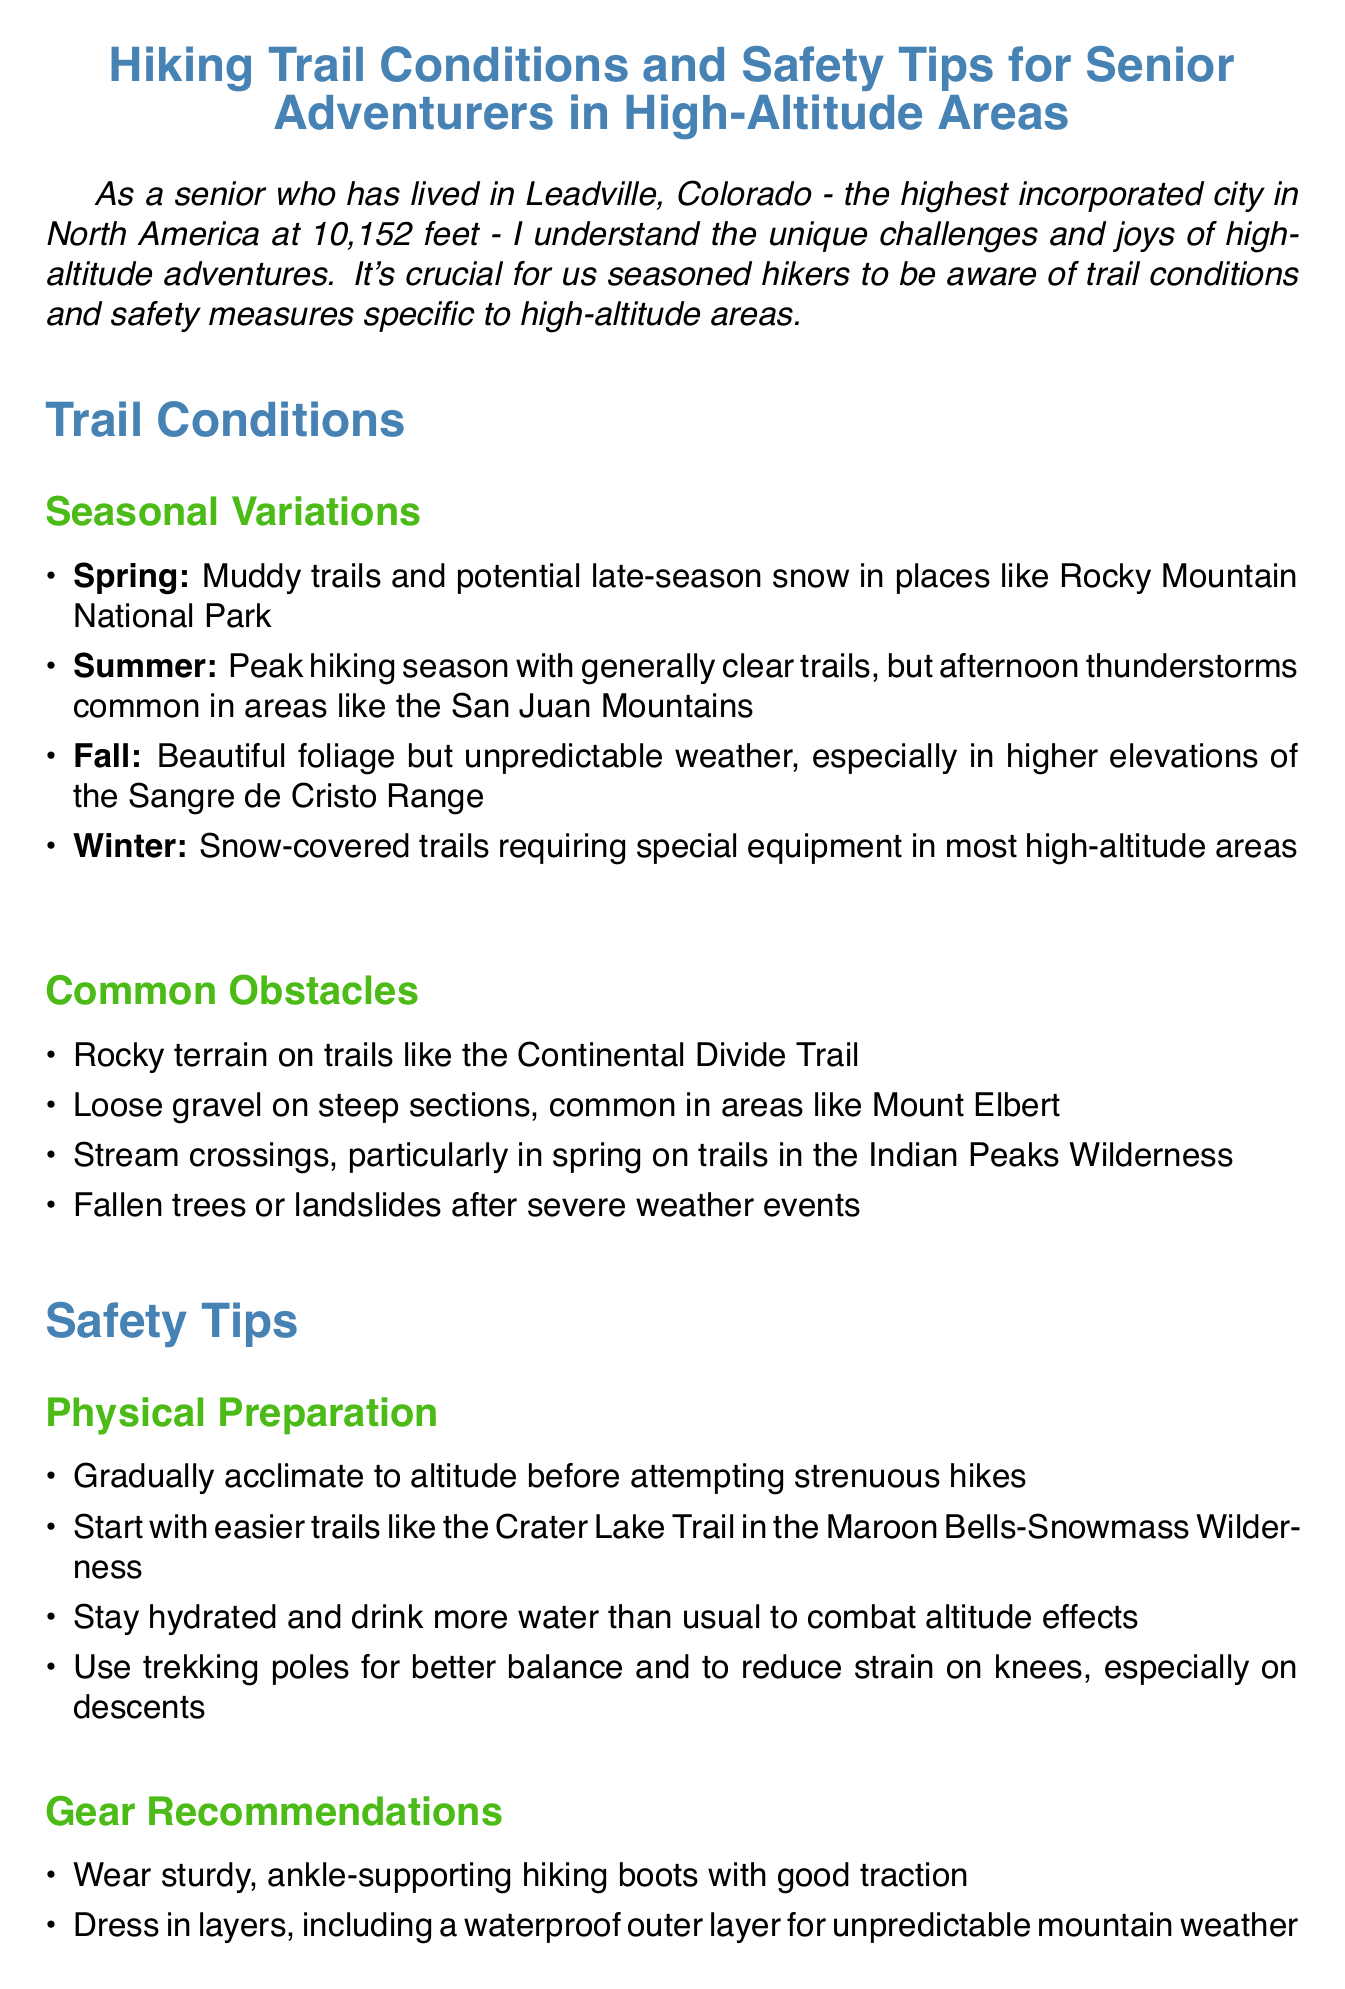What is the memo about? The memo outlines hiking trail conditions and safety tips specifically for senior adventurers in high-altitude areas.
Answer: Hiking Trail Conditions and Safety Tips for Senior Adventurers in High-Altitude Areas What altitude is Leadville, Colorado? The memo states that Leadville, Colorado is at an altitude of 10,152 feet.
Answer: 10,152 feet Which season features muddy trails? The memo indicates that spring has muddy trails and potential late-season snow.
Answer: Spring What should hikers carry for emergency preparedness? The memo lists packing an emergency shelter like a lightweight space blanket as a recommendation.
Answer: Emergency shelter like a lightweight space blanket What is a recommended practice for physical preparation before hiking? The document advises gradually acclimating to altitude before attempting strenuous hikes.
Answer: Gradually acclimate to altitude Which trail is suggested for easier hikes? The memo suggests starting with Crater Lake Trail in the Maroon Bells-Snowmass Wilderness.
Answer: Crater Lake Trail in the Maroon Bells-Snowmass Wilderness How can seniors know weather conditions before hiking? The memo advises checking weather forecasts before setting out on a hike.
Answer: Check weather forecasts What is the recommended time to start hikes to avoid afternoon thunderstorms? The memo recommends starting early to avoid afternoon thunderstorms common in certain areas.
Answer: Start early What gear is recommended to protect against sun exposure? The memo recommends using a hat, sunglasses, and high-SPF sunscreen due to increased UV exposure.
Answer: Hat, sunglasses, and high-SPF sunscreen 